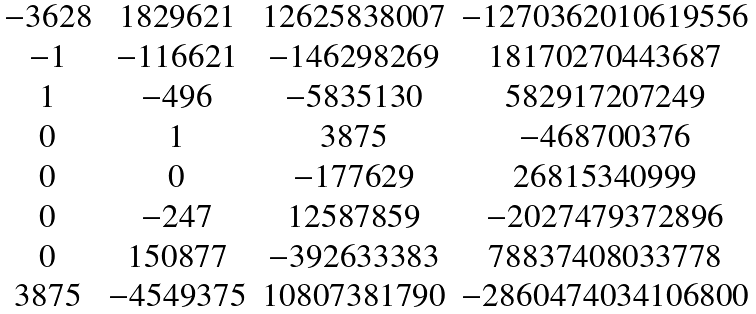Convert formula to latex. <formula><loc_0><loc_0><loc_500><loc_500>\begin{matrix} - 3 6 2 8 & 1 8 2 9 6 2 1 & 1 2 6 2 5 8 3 8 0 0 7 & - 1 2 7 0 3 6 2 0 1 0 6 1 9 5 5 6 \\ - 1 & - 1 1 6 6 2 1 & - 1 4 6 2 9 8 2 6 9 & 1 8 1 7 0 2 7 0 4 4 3 6 8 7 \\ 1 & - 4 9 6 & - 5 8 3 5 1 3 0 & 5 8 2 9 1 7 2 0 7 2 4 9 \\ 0 & 1 & 3 8 7 5 & - 4 6 8 7 0 0 3 7 6 \\ 0 & 0 & - 1 7 7 6 2 9 & 2 6 8 1 5 3 4 0 9 9 9 \\ 0 & - 2 4 7 & 1 2 5 8 7 8 5 9 & - 2 0 2 7 4 7 9 3 7 2 8 9 6 \\ 0 & 1 5 0 8 7 7 & - 3 9 2 6 3 3 3 8 3 & 7 8 8 3 7 4 0 8 0 3 3 7 7 8 \\ 3 8 7 5 & - 4 5 4 9 3 7 5 & 1 0 8 0 7 3 8 1 7 9 0 & - 2 8 6 0 4 7 4 0 3 4 1 0 6 8 0 0 \\ \end{matrix}</formula> 